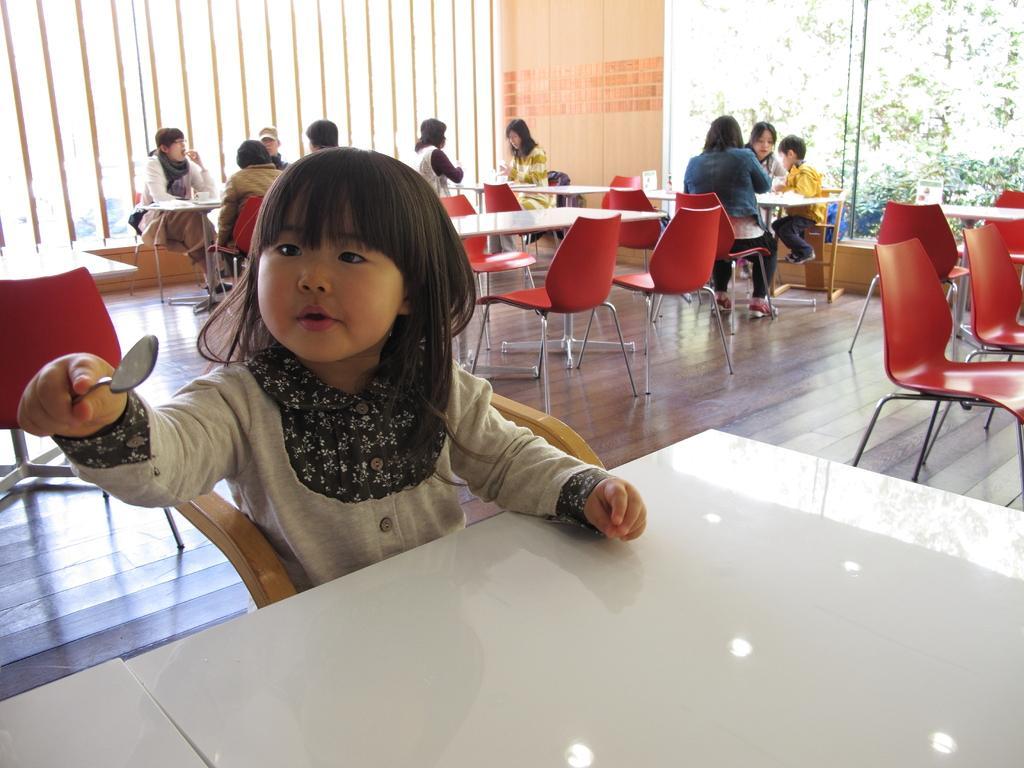Could you give a brief overview of what you see in this image? This image consists of a girl sitting on the chair before a table. At the right side there are few chairs and table. Middle of the image few persons are sitting on the chair. Left side a boy is wearing a yellow shirt. At the background there are few trees. 